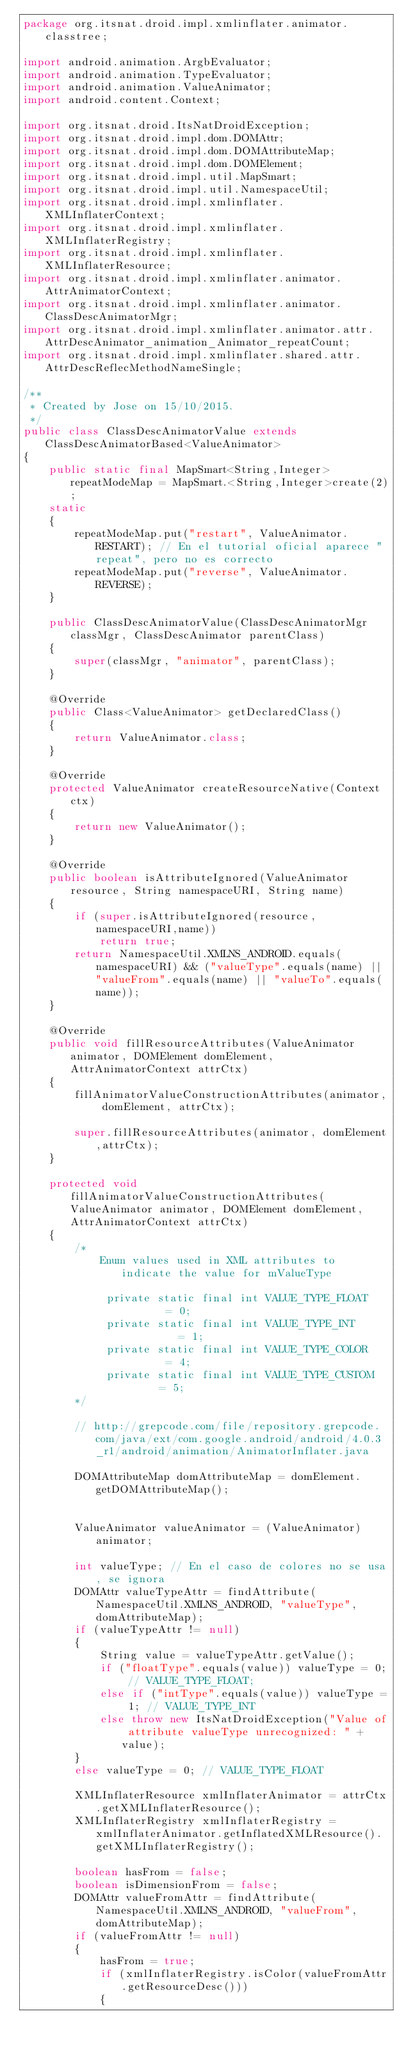<code> <loc_0><loc_0><loc_500><loc_500><_Java_>package org.itsnat.droid.impl.xmlinflater.animator.classtree;

import android.animation.ArgbEvaluator;
import android.animation.TypeEvaluator;
import android.animation.ValueAnimator;
import android.content.Context;

import org.itsnat.droid.ItsNatDroidException;
import org.itsnat.droid.impl.dom.DOMAttr;
import org.itsnat.droid.impl.dom.DOMAttributeMap;
import org.itsnat.droid.impl.dom.DOMElement;
import org.itsnat.droid.impl.util.MapSmart;
import org.itsnat.droid.impl.util.NamespaceUtil;
import org.itsnat.droid.impl.xmlinflater.XMLInflaterContext;
import org.itsnat.droid.impl.xmlinflater.XMLInflaterRegistry;
import org.itsnat.droid.impl.xmlinflater.XMLInflaterResource;
import org.itsnat.droid.impl.xmlinflater.animator.AttrAnimatorContext;
import org.itsnat.droid.impl.xmlinflater.animator.ClassDescAnimatorMgr;
import org.itsnat.droid.impl.xmlinflater.animator.attr.AttrDescAnimator_animation_Animator_repeatCount;
import org.itsnat.droid.impl.xmlinflater.shared.attr.AttrDescReflecMethodNameSingle;

/**
 * Created by Jose on 15/10/2015.
 */
public class ClassDescAnimatorValue extends ClassDescAnimatorBased<ValueAnimator>
{
    public static final MapSmart<String,Integer> repeatModeMap = MapSmart.<String,Integer>create(2);
    static
    {
        repeatModeMap.put("restart", ValueAnimator.RESTART); // En el tutorial oficial aparece "repeat", pero no es correcto
        repeatModeMap.put("reverse", ValueAnimator.REVERSE);
    }

    public ClassDescAnimatorValue(ClassDescAnimatorMgr classMgr, ClassDescAnimator parentClass)
    {
        super(classMgr, "animator", parentClass);
    }

    @Override
    public Class<ValueAnimator> getDeclaredClass()
    {
        return ValueAnimator.class;
    }

    @Override
    protected ValueAnimator createResourceNative(Context ctx)
    {
        return new ValueAnimator();
    }

    @Override
    public boolean isAttributeIgnored(ValueAnimator resource, String namespaceURI, String name)
    {
        if (super.isAttributeIgnored(resource,namespaceURI,name))
            return true;
        return NamespaceUtil.XMLNS_ANDROID.equals(namespaceURI) && ("valueType".equals(name) || "valueFrom".equals(name) || "valueTo".equals(name));
    }

    @Override
    public void fillResourceAttributes(ValueAnimator animator, DOMElement domElement,  AttrAnimatorContext attrCtx)
    {
        fillAnimatorValueConstructionAttributes(animator, domElement, attrCtx);

        super.fillResourceAttributes(animator, domElement,attrCtx);
    }

    protected void fillAnimatorValueConstructionAttributes(ValueAnimator animator, DOMElement domElement, AttrAnimatorContext attrCtx)
    {
        /*
            Enum values used in XML attributes to indicate the value for mValueType

             private static final int VALUE_TYPE_FLOAT       = 0;
             private static final int VALUE_TYPE_INT         = 1;
             private static final int VALUE_TYPE_COLOR       = 4;
             private static final int VALUE_TYPE_CUSTOM      = 5;
        */

        // http://grepcode.com/file/repository.grepcode.com/java/ext/com.google.android/android/4.0.3_r1/android/animation/AnimatorInflater.java

        DOMAttributeMap domAttributeMap = domElement.getDOMAttributeMap();


        ValueAnimator valueAnimator = (ValueAnimator)animator;

        int valueType; // En el caso de colores no se usa, se ignora
        DOMAttr valueTypeAttr = findAttribute(NamespaceUtil.XMLNS_ANDROID, "valueType",domAttributeMap);
        if (valueTypeAttr != null)
        {
            String value = valueTypeAttr.getValue();
            if ("floatType".equals(value)) valueType = 0; // VALUE_TYPE_FLOAT;
            else if ("intType".equals(value)) valueType = 1; // VALUE_TYPE_INT
            else throw new ItsNatDroidException("Value of attribute valueType unrecognized: " + value);
        }
        else valueType = 0; // VALUE_TYPE_FLOAT

        XMLInflaterResource xmlInflaterAnimator = attrCtx.getXMLInflaterResource();
        XMLInflaterRegistry xmlInflaterRegistry = xmlInflaterAnimator.getInflatedXMLResource().getXMLInflaterRegistry();

        boolean hasFrom = false;
        boolean isDimensionFrom = false;
        DOMAttr valueFromAttr = findAttribute(NamespaceUtil.XMLNS_ANDROID, "valueFrom",domAttributeMap);
        if (valueFromAttr != null)
        {
            hasFrom = true;
            if (xmlInflaterRegistry.isColor(valueFromAttr.getResourceDesc()))
            {</code> 